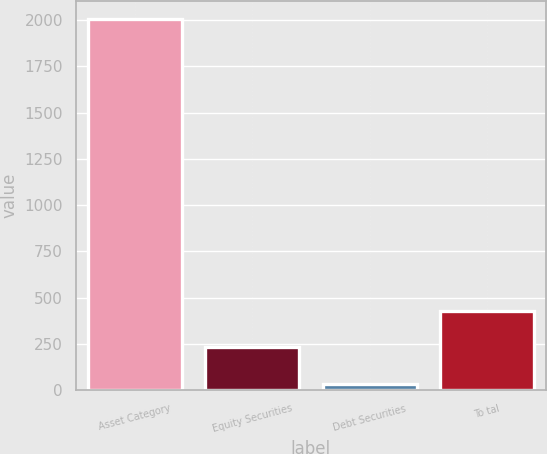<chart> <loc_0><loc_0><loc_500><loc_500><bar_chart><fcel>Asset Category<fcel>Equity Securities<fcel>Debt Securities<fcel>To tal<nl><fcel>2004<fcel>231.9<fcel>35<fcel>428.8<nl></chart> 